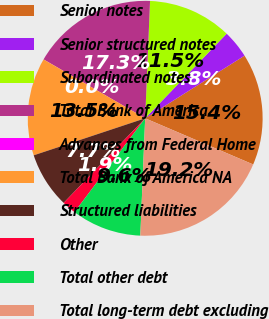Convert chart. <chart><loc_0><loc_0><loc_500><loc_500><pie_chart><fcel>Senior notes<fcel>Senior structured notes<fcel>Subordinated notes<fcel>Total Bank of America<fcel>Advances from Federal Home<fcel>Total Bank of America NA<fcel>Structured liabilities<fcel>Other<fcel>Total other debt<fcel>Total long-term debt excluding<nl><fcel>15.38%<fcel>3.85%<fcel>11.54%<fcel>17.3%<fcel>0.01%<fcel>13.46%<fcel>7.69%<fcel>1.93%<fcel>9.62%<fcel>19.23%<nl></chart> 